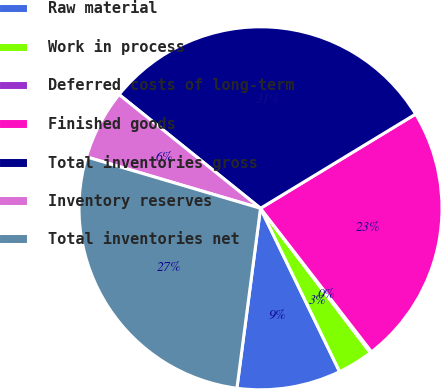Convert chart to OTSL. <chart><loc_0><loc_0><loc_500><loc_500><pie_chart><fcel>Raw material<fcel>Work in process<fcel>Deferred costs of long-term<fcel>Finished goods<fcel>Total inventories gross<fcel>Inventory reserves<fcel>Total inventories net<nl><fcel>9.25%<fcel>3.17%<fcel>0.13%<fcel>23.21%<fcel>30.53%<fcel>6.21%<fcel>27.49%<nl></chart> 